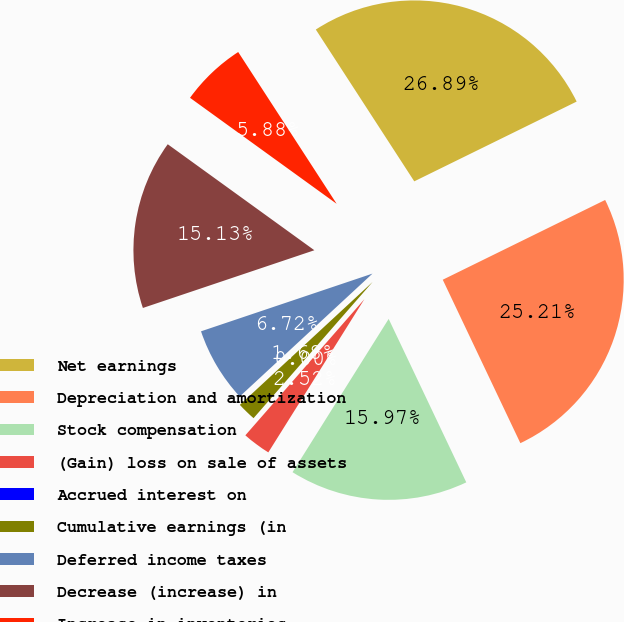<chart> <loc_0><loc_0><loc_500><loc_500><pie_chart><fcel>Net earnings<fcel>Depreciation and amortization<fcel>Stock compensation<fcel>(Gain) loss on sale of assets<fcel>Accrued interest on<fcel>Cumulative earnings (in<fcel>Deferred income taxes<fcel>Decrease (increase) in<fcel>Increase in inventories<nl><fcel>26.89%<fcel>25.21%<fcel>15.97%<fcel>2.52%<fcel>0.0%<fcel>1.68%<fcel>6.72%<fcel>15.13%<fcel>5.88%<nl></chart> 